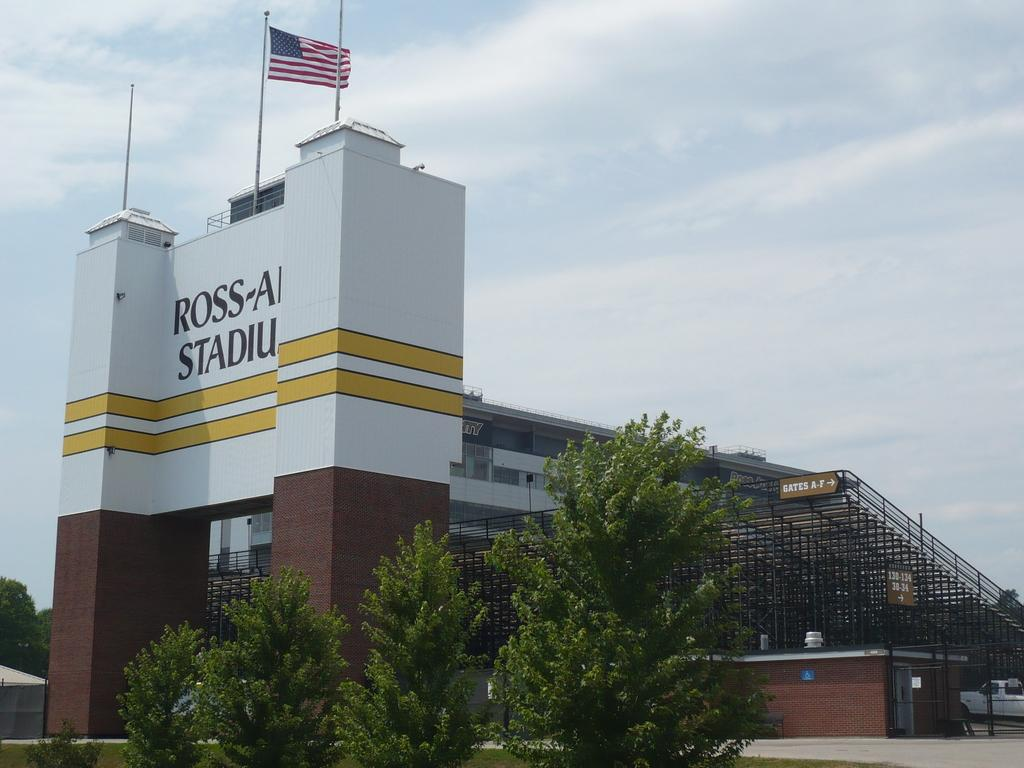<image>
Write a terse but informative summary of the picture. The Ross-Ade Stadium with a sign for Gates A-F 